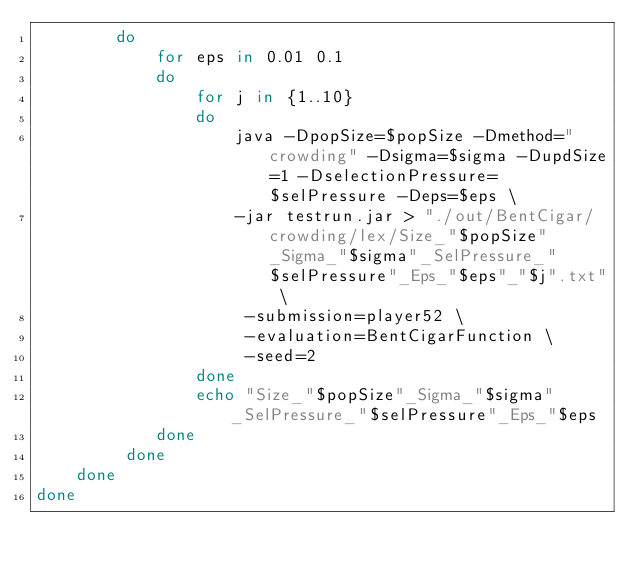Convert code to text. <code><loc_0><loc_0><loc_500><loc_500><_Bash_>        do
            for eps in 0.01 0.1
            do
                for j in {1..10}
                do
                    java -DpopSize=$popSize -Dmethod="crowding" -Dsigma=$sigma -DupdSize=1 -DselectionPressure=$selPressure -Deps=$eps \
                    -jar testrun.jar > "./out/BentCigar/crowding/lex/Size_"$popSize"_Sigma_"$sigma"_SelPressure_"$selPressure"_Eps_"$eps"_"$j".txt" \
                     -submission=player52 \
                     -evaluation=BentCigarFunction \
                     -seed=2
                done
                echo "Size_"$popSize"_Sigma_"$sigma"_SelPressure_"$selPressure"_Eps_"$eps
            done
         done
    done
done</code> 